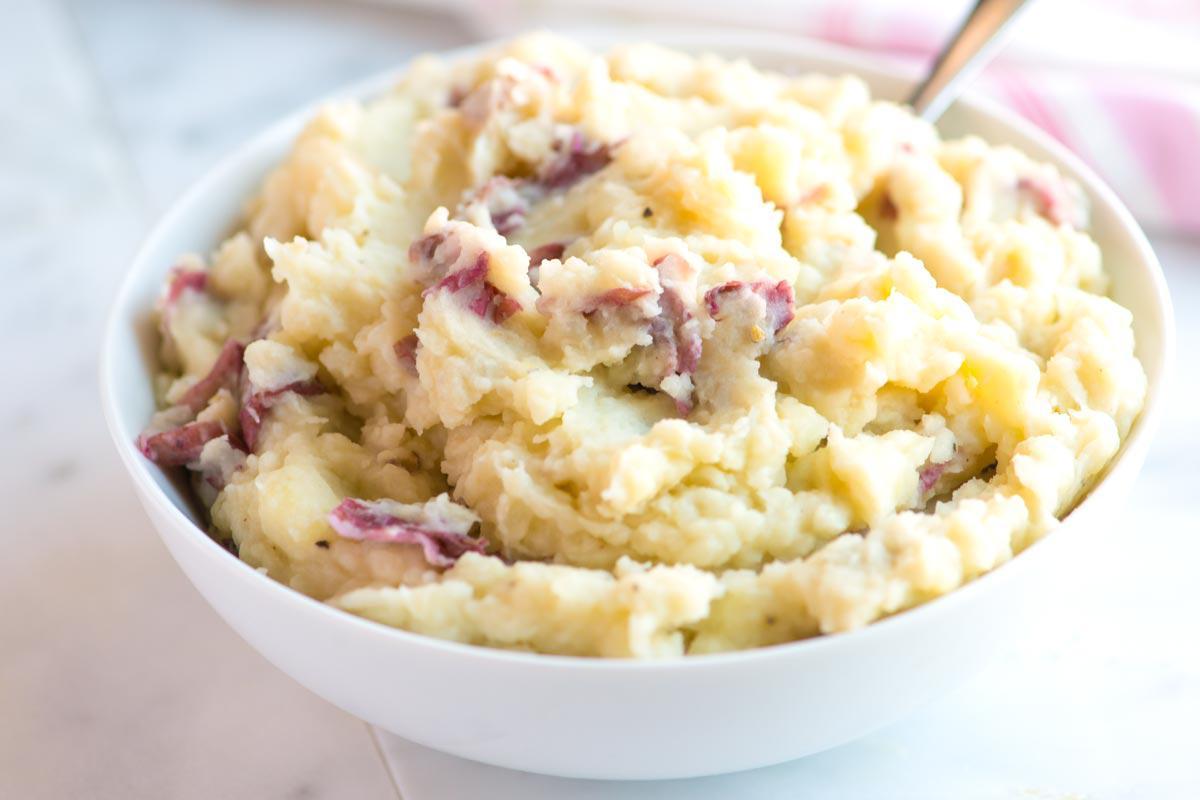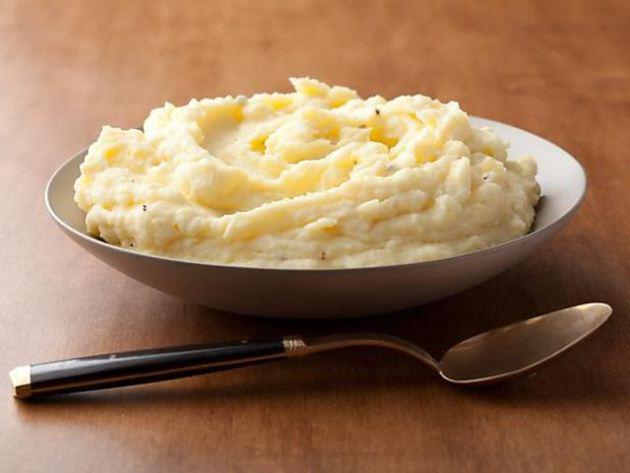The first image is the image on the left, the second image is the image on the right. For the images shown, is this caption "One image shows a round bowl of mashed potatoes with the handle of a piece of silverware sticking out of it." true? Answer yes or no. Yes. The first image is the image on the left, the second image is the image on the right. For the images displayed, is the sentence "A eating utensil is visible in the right image." factually correct? Answer yes or no. Yes. 